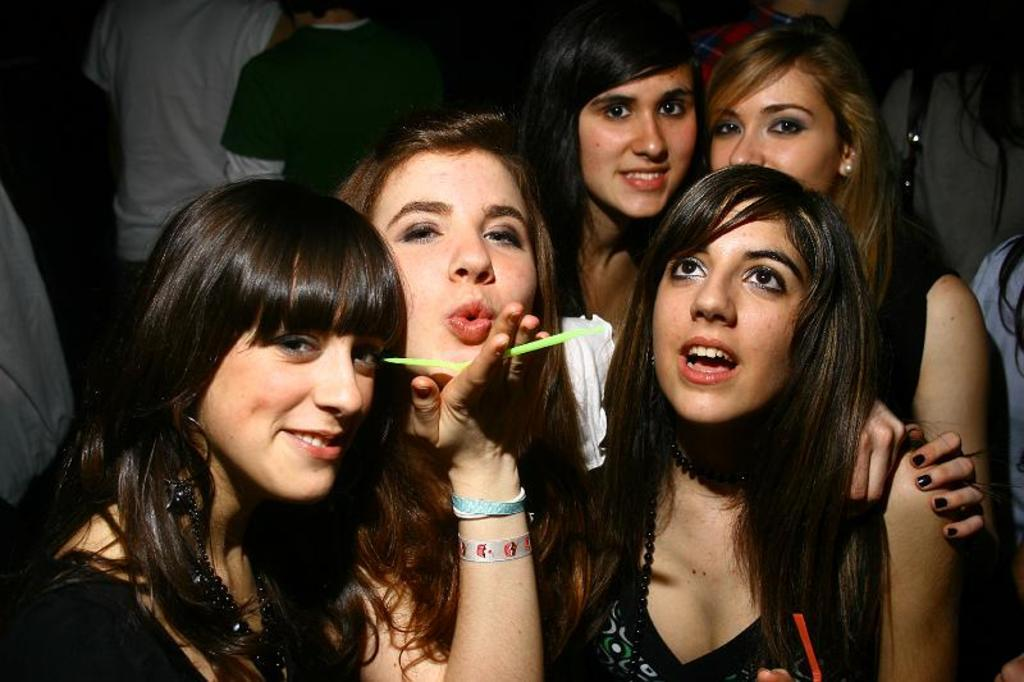How many women are in the middle of the picture? There are five women in the middle of the picture. Can you describe the people in the background of the image? Unfortunately, the provided facts do not give any information about the people in the background. What type of bird is tied in a knot in the image? There is no bird or knot present in the image. 